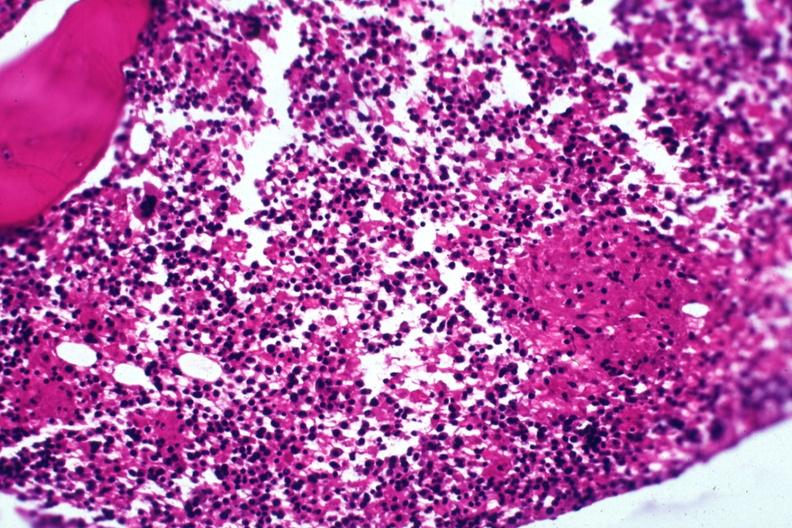does this image show section granuloma shown but not too typical?
Answer the question using a single word or phrase. Yes 